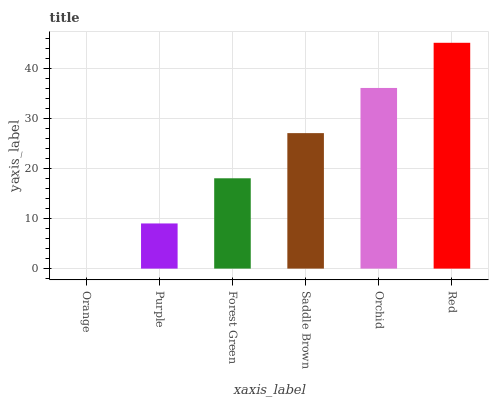Is Orange the minimum?
Answer yes or no. Yes. Is Red the maximum?
Answer yes or no. Yes. Is Purple the minimum?
Answer yes or no. No. Is Purple the maximum?
Answer yes or no. No. Is Purple greater than Orange?
Answer yes or no. Yes. Is Orange less than Purple?
Answer yes or no. Yes. Is Orange greater than Purple?
Answer yes or no. No. Is Purple less than Orange?
Answer yes or no. No. Is Saddle Brown the high median?
Answer yes or no. Yes. Is Forest Green the low median?
Answer yes or no. Yes. Is Purple the high median?
Answer yes or no. No. Is Saddle Brown the low median?
Answer yes or no. No. 